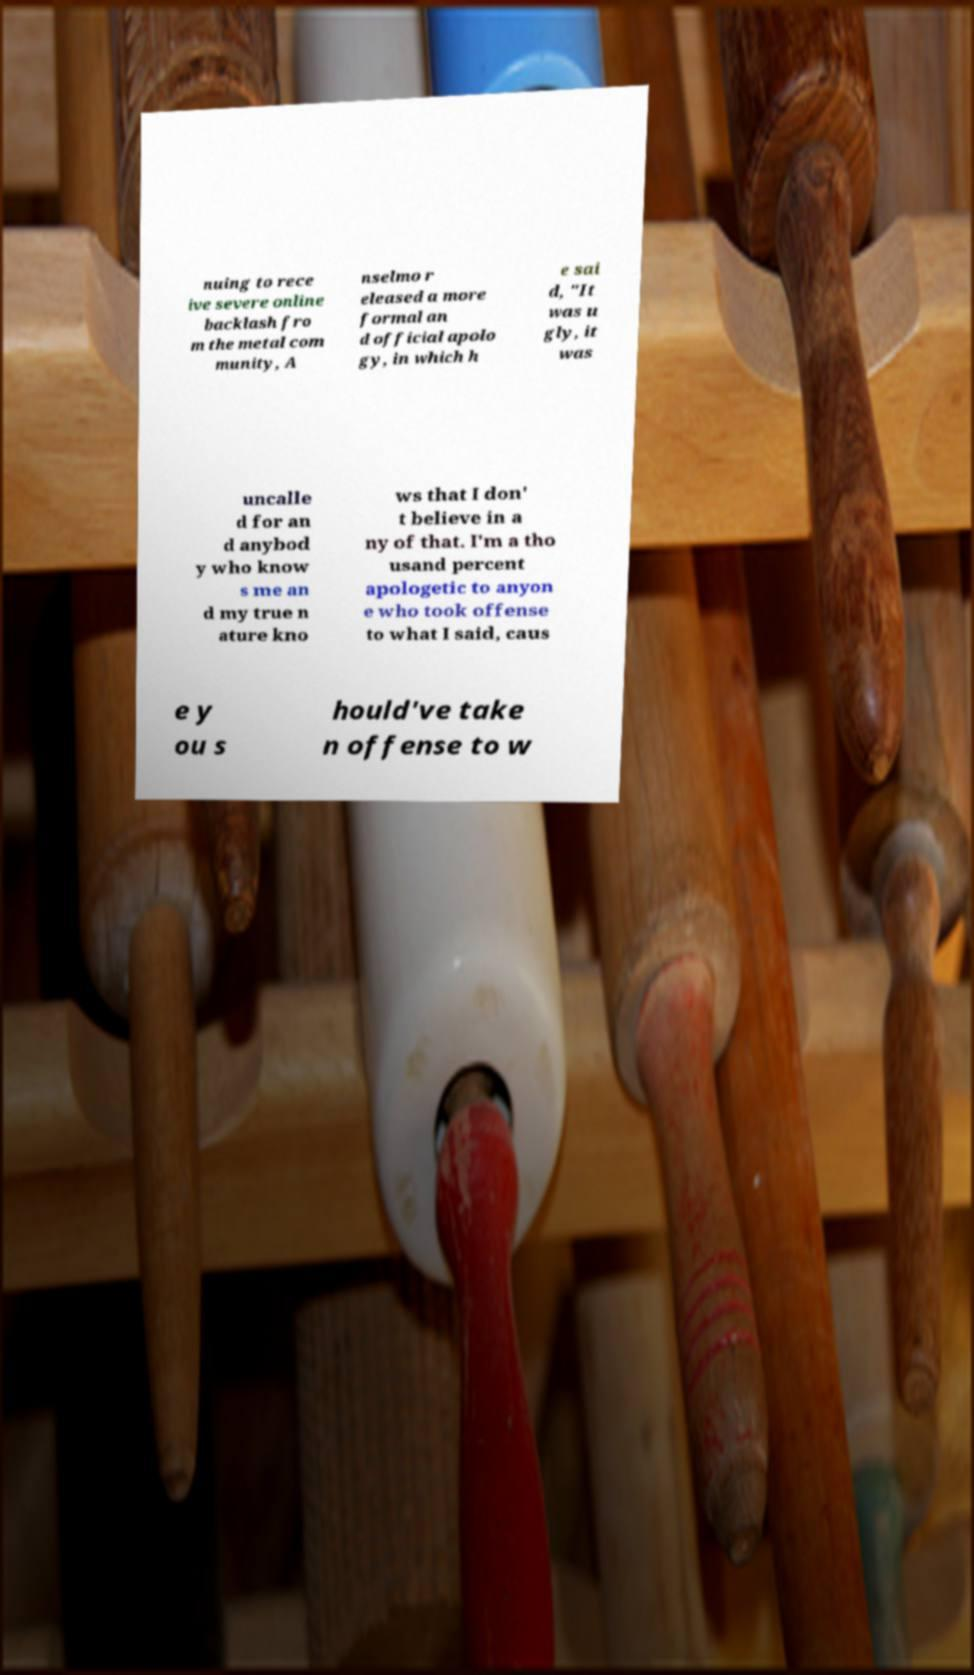For documentation purposes, I need the text within this image transcribed. Could you provide that? nuing to rece ive severe online backlash fro m the metal com munity, A nselmo r eleased a more formal an d official apolo gy, in which h e sai d, "It was u gly, it was uncalle d for an d anybod y who know s me an d my true n ature kno ws that I don' t believe in a ny of that. I'm a tho usand percent apologetic to anyon e who took offense to what I said, caus e y ou s hould've take n offense to w 